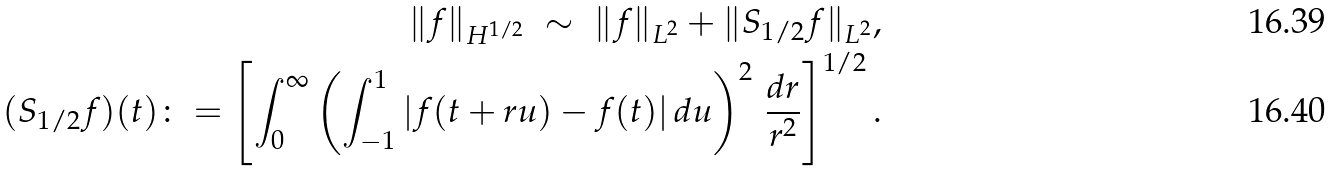Convert formula to latex. <formula><loc_0><loc_0><loc_500><loc_500>\| f \| _ { H ^ { 1 / 2 } } \ \sim \ \| f \| _ { L ^ { 2 } } + \| S _ { 1 / 2 } f \| _ { L ^ { 2 } } , \\ ( S _ { 1 / 2 } f ) ( t ) \colon = \left [ \int _ { 0 } ^ { \infty } \left ( \int _ { - 1 } ^ { 1 } | f ( t + r u ) - f ( t ) | \, d u \right ) ^ { 2 } \, \frac { d r } { r ^ { 2 } } \right ] ^ { 1 / 2 } .</formula> 